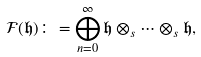Convert formula to latex. <formula><loc_0><loc_0><loc_500><loc_500>\mathcal { F } ( \mathfrak { h } ) \colon = \bigoplus _ { n = 0 } ^ { \infty } \mathfrak { h } \otimes _ { s } \dots \otimes _ { s } \mathfrak { h } ,</formula> 